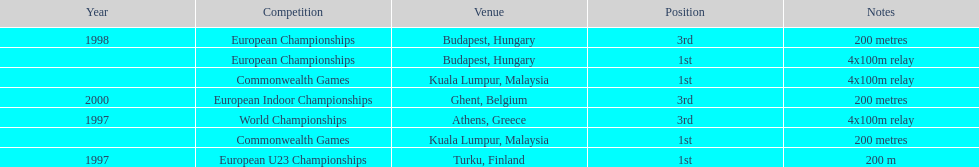List the other competitions besides european u23 championship that came in 1st position? European Championships, Commonwealth Games, Commonwealth Games. 